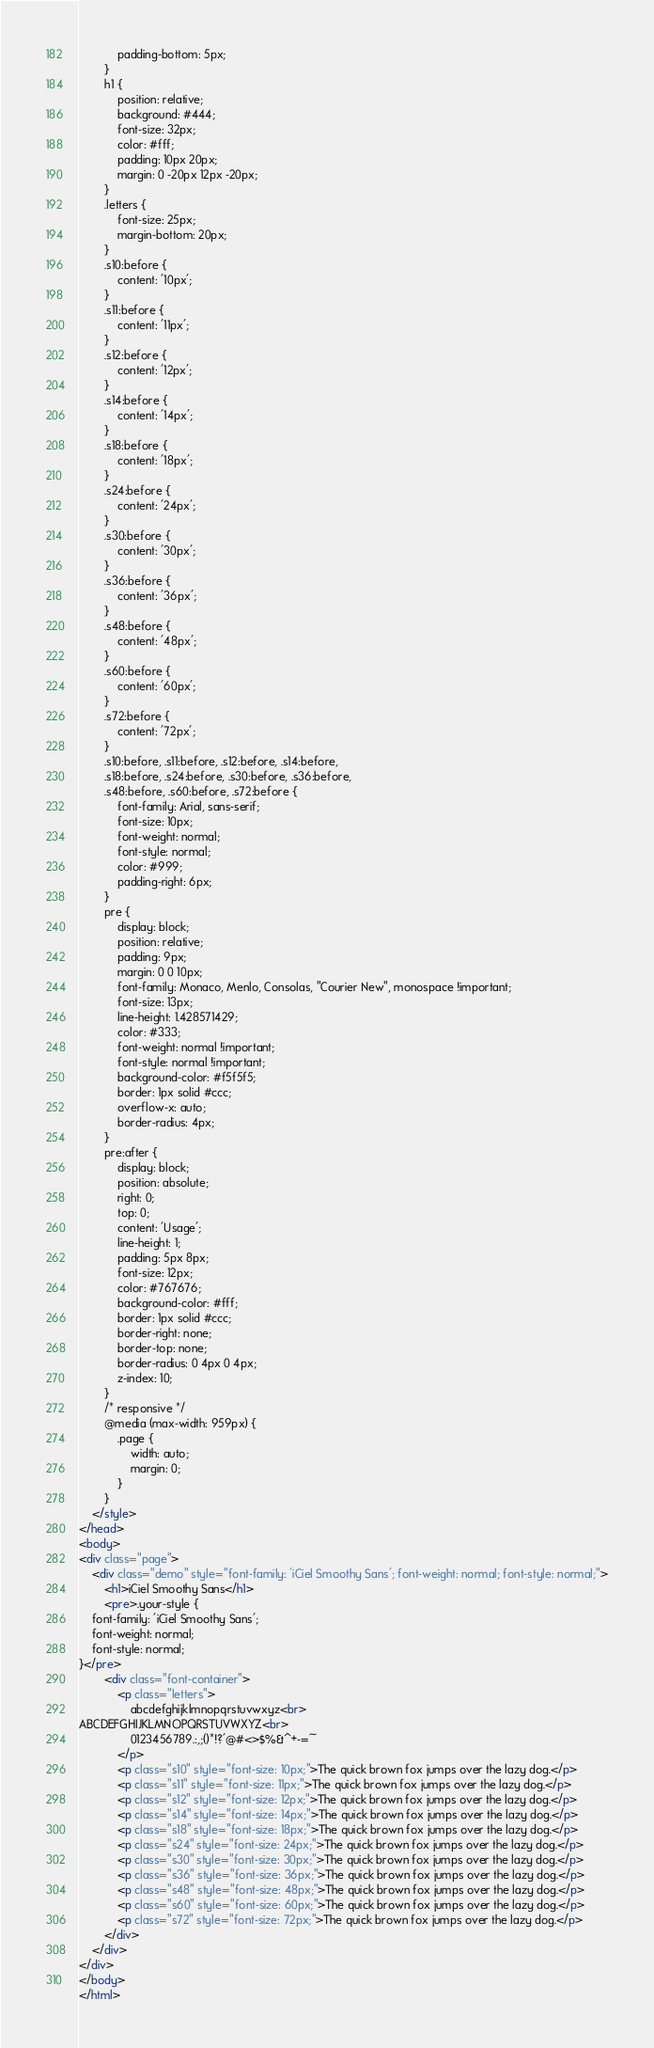Convert code to text. <code><loc_0><loc_0><loc_500><loc_500><_HTML_>            padding-bottom: 5px;
        }
        h1 {
            position: relative;
            background: #444;
            font-size: 32px;
            color: #fff;
            padding: 10px 20px;
            margin: 0 -20px 12px -20px;
        }
        .letters {
            font-size: 25px;
            margin-bottom: 20px;
        }
        .s10:before {
            content: '10px';
        }
        .s11:before {
            content: '11px';
        }
        .s12:before {
            content: '12px';
        }
        .s14:before {
            content: '14px';
        }
        .s18:before {
            content: '18px';
        }
        .s24:before {
            content: '24px';
        }
        .s30:before {
            content: '30px';
        }
        .s36:before {
            content: '36px';
        }
        .s48:before {
            content: '48px';
        }
        .s60:before {
            content: '60px';
        }
        .s72:before {
            content: '72px';
        }
        .s10:before, .s11:before, .s12:before, .s14:before,
        .s18:before, .s24:before, .s30:before, .s36:before,
        .s48:before, .s60:before, .s72:before {
            font-family: Arial, sans-serif;
            font-size: 10px;
            font-weight: normal;
            font-style: normal;
            color: #999;
            padding-right: 6px;
        }
        pre {
            display: block;
            position: relative;
            padding: 9px;
            margin: 0 0 10px;
            font-family: Monaco, Menlo, Consolas, "Courier New", monospace !important;
            font-size: 13px;
            line-height: 1.428571429;
            color: #333;
            font-weight: normal !important;
            font-style: normal !important;
            background-color: #f5f5f5;
            border: 1px solid #ccc;
            overflow-x: auto;
            border-radius: 4px;
        }
        pre:after {
            display: block;
            position: absolute;
            right: 0;
            top: 0;
            content: 'Usage';
            line-height: 1;
            padding: 5px 8px;
            font-size: 12px;
            color: #767676;
            background-color: #fff;
            border: 1px solid #ccc;
            border-right: none;
            border-top: none;
            border-radius: 0 4px 0 4px;
            z-index: 10;
        }
        /* responsive */
        @media (max-width: 959px) {
            .page {
                width: auto;
                margin: 0;
            }
        }
    </style>
</head>
<body>
<div class="page">
    <div class="demo" style="font-family: 'iCiel Smoothy Sans'; font-weight: normal; font-style: normal;">
        <h1>iCiel Smoothy Sans</h1>
        <pre>.your-style {
    font-family: 'iCiel Smoothy Sans';
    font-weight: normal;
    font-style: normal;
}</pre>
        <div class="font-container">
            <p class="letters">
                abcdefghijklmnopqrstuvwxyz<br>
ABCDEFGHIJKLMNOPQRSTUVWXYZ<br>
                0123456789.:,;()*!?'@#<>$%&^+-=~
            </p>
            <p class="s10" style="font-size: 10px;">The quick brown fox jumps over the lazy dog.</p>
            <p class="s11" style="font-size: 11px;">The quick brown fox jumps over the lazy dog.</p>
            <p class="s12" style="font-size: 12px;">The quick brown fox jumps over the lazy dog.</p>
            <p class="s14" style="font-size: 14px;">The quick brown fox jumps over the lazy dog.</p>
            <p class="s18" style="font-size: 18px;">The quick brown fox jumps over the lazy dog.</p>
            <p class="s24" style="font-size: 24px;">The quick brown fox jumps over the lazy dog.</p>
            <p class="s30" style="font-size: 30px;">The quick brown fox jumps over the lazy dog.</p>
            <p class="s36" style="font-size: 36px;">The quick brown fox jumps over the lazy dog.</p>
            <p class="s48" style="font-size: 48px;">The quick brown fox jumps over the lazy dog.</p>
            <p class="s60" style="font-size: 60px;">The quick brown fox jumps over the lazy dog.</p>
            <p class="s72" style="font-size: 72px;">The quick brown fox jumps over the lazy dog.</p>
        </div>
    </div>
</div>
</body>
</html></code> 